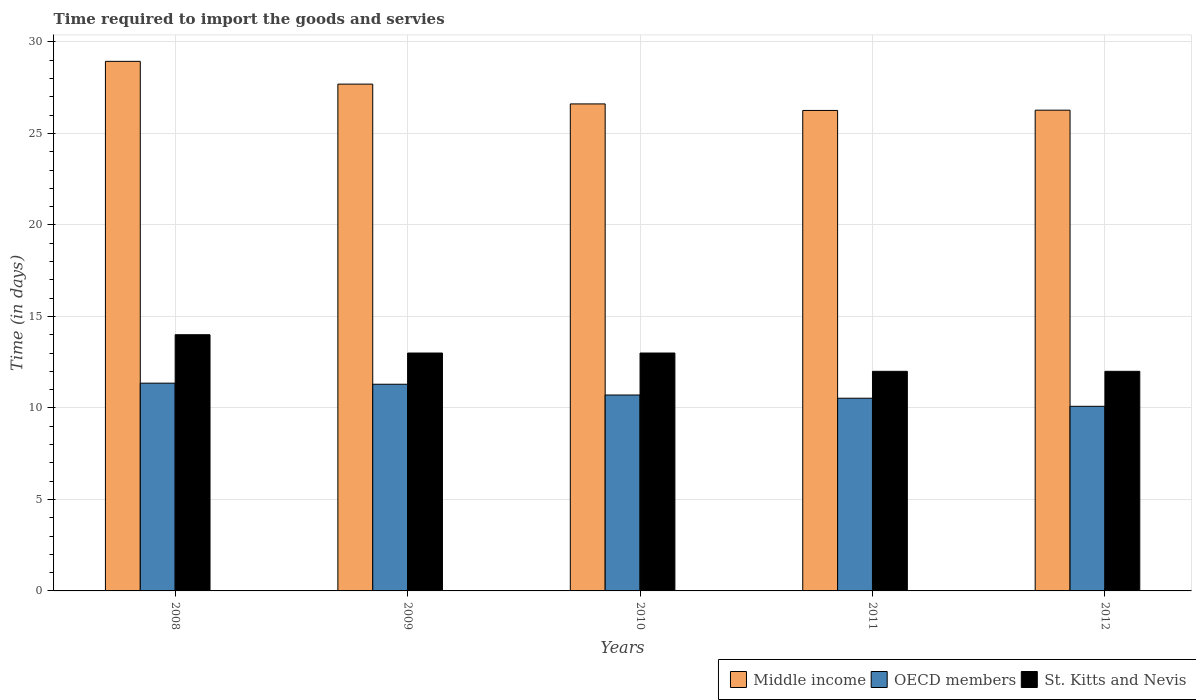How many groups of bars are there?
Provide a succinct answer. 5. In how many cases, is the number of bars for a given year not equal to the number of legend labels?
Your answer should be very brief. 0. What is the number of days required to import the goods and services in Middle income in 2009?
Provide a short and direct response. 27.69. Across all years, what is the maximum number of days required to import the goods and services in St. Kitts and Nevis?
Your response must be concise. 14. Across all years, what is the minimum number of days required to import the goods and services in St. Kitts and Nevis?
Provide a short and direct response. 12. In which year was the number of days required to import the goods and services in Middle income maximum?
Offer a very short reply. 2008. In which year was the number of days required to import the goods and services in Middle income minimum?
Your response must be concise. 2011. What is the total number of days required to import the goods and services in St. Kitts and Nevis in the graph?
Keep it short and to the point. 64. What is the difference between the number of days required to import the goods and services in OECD members in 2008 and that in 2011?
Provide a short and direct response. 0.82. What is the difference between the number of days required to import the goods and services in St. Kitts and Nevis in 2008 and the number of days required to import the goods and services in Middle income in 2012?
Provide a short and direct response. -12.27. What is the average number of days required to import the goods and services in St. Kitts and Nevis per year?
Ensure brevity in your answer.  12.8. In the year 2011, what is the difference between the number of days required to import the goods and services in Middle income and number of days required to import the goods and services in OECD members?
Ensure brevity in your answer.  15.73. In how many years, is the number of days required to import the goods and services in St. Kitts and Nevis greater than 14 days?
Keep it short and to the point. 0. What is the ratio of the number of days required to import the goods and services in Middle income in 2011 to that in 2012?
Offer a very short reply. 1. Is the number of days required to import the goods and services in St. Kitts and Nevis in 2011 less than that in 2012?
Offer a terse response. No. Is the difference between the number of days required to import the goods and services in Middle income in 2008 and 2010 greater than the difference between the number of days required to import the goods and services in OECD members in 2008 and 2010?
Your response must be concise. Yes. What is the difference between the highest and the second highest number of days required to import the goods and services in St. Kitts and Nevis?
Your response must be concise. 1. What is the difference between the highest and the lowest number of days required to import the goods and services in OECD members?
Make the answer very short. 1.26. Is the sum of the number of days required to import the goods and services in St. Kitts and Nevis in 2009 and 2010 greater than the maximum number of days required to import the goods and services in Middle income across all years?
Your answer should be compact. No. What does the 1st bar from the left in 2010 represents?
Your response must be concise. Middle income. What does the 1st bar from the right in 2009 represents?
Make the answer very short. St. Kitts and Nevis. How many bars are there?
Ensure brevity in your answer.  15. How many years are there in the graph?
Offer a very short reply. 5. Are the values on the major ticks of Y-axis written in scientific E-notation?
Offer a very short reply. No. Where does the legend appear in the graph?
Provide a short and direct response. Bottom right. How many legend labels are there?
Make the answer very short. 3. How are the legend labels stacked?
Offer a very short reply. Horizontal. What is the title of the graph?
Your answer should be very brief. Time required to import the goods and servies. What is the label or title of the Y-axis?
Give a very brief answer. Time (in days). What is the Time (in days) of Middle income in 2008?
Your response must be concise. 28.94. What is the Time (in days) of OECD members in 2008?
Keep it short and to the point. 11.35. What is the Time (in days) of Middle income in 2009?
Offer a very short reply. 27.69. What is the Time (in days) of OECD members in 2009?
Ensure brevity in your answer.  11.29. What is the Time (in days) of Middle income in 2010?
Offer a terse response. 26.61. What is the Time (in days) in OECD members in 2010?
Keep it short and to the point. 10.71. What is the Time (in days) of St. Kitts and Nevis in 2010?
Make the answer very short. 13. What is the Time (in days) of Middle income in 2011?
Provide a succinct answer. 26.26. What is the Time (in days) of OECD members in 2011?
Your answer should be very brief. 10.53. What is the Time (in days) of St. Kitts and Nevis in 2011?
Offer a terse response. 12. What is the Time (in days) of Middle income in 2012?
Ensure brevity in your answer.  26.27. What is the Time (in days) in OECD members in 2012?
Ensure brevity in your answer.  10.09. Across all years, what is the maximum Time (in days) of Middle income?
Ensure brevity in your answer.  28.94. Across all years, what is the maximum Time (in days) in OECD members?
Ensure brevity in your answer.  11.35. Across all years, what is the maximum Time (in days) of St. Kitts and Nevis?
Offer a very short reply. 14. Across all years, what is the minimum Time (in days) in Middle income?
Your answer should be very brief. 26.26. Across all years, what is the minimum Time (in days) of OECD members?
Your answer should be very brief. 10.09. What is the total Time (in days) in Middle income in the graph?
Your answer should be very brief. 135.77. What is the total Time (in days) of OECD members in the graph?
Provide a short and direct response. 53.97. What is the difference between the Time (in days) in Middle income in 2008 and that in 2009?
Your answer should be compact. 1.24. What is the difference between the Time (in days) in OECD members in 2008 and that in 2009?
Give a very brief answer. 0.06. What is the difference between the Time (in days) of Middle income in 2008 and that in 2010?
Your answer should be compact. 2.33. What is the difference between the Time (in days) of OECD members in 2008 and that in 2010?
Your answer should be very brief. 0.65. What is the difference between the Time (in days) of St. Kitts and Nevis in 2008 and that in 2010?
Keep it short and to the point. 1. What is the difference between the Time (in days) of Middle income in 2008 and that in 2011?
Make the answer very short. 2.68. What is the difference between the Time (in days) of OECD members in 2008 and that in 2011?
Offer a very short reply. 0.82. What is the difference between the Time (in days) in St. Kitts and Nevis in 2008 and that in 2011?
Provide a succinct answer. 2. What is the difference between the Time (in days) of Middle income in 2008 and that in 2012?
Offer a very short reply. 2.67. What is the difference between the Time (in days) in OECD members in 2008 and that in 2012?
Your response must be concise. 1.26. What is the difference between the Time (in days) in Middle income in 2009 and that in 2010?
Your answer should be very brief. 1.08. What is the difference between the Time (in days) in OECD members in 2009 and that in 2010?
Offer a very short reply. 0.59. What is the difference between the Time (in days) of Middle income in 2009 and that in 2011?
Provide a short and direct response. 1.44. What is the difference between the Time (in days) in OECD members in 2009 and that in 2011?
Provide a short and direct response. 0.76. What is the difference between the Time (in days) in St. Kitts and Nevis in 2009 and that in 2011?
Give a very brief answer. 1. What is the difference between the Time (in days) of Middle income in 2009 and that in 2012?
Provide a succinct answer. 1.42. What is the difference between the Time (in days) in OECD members in 2009 and that in 2012?
Make the answer very short. 1.21. What is the difference between the Time (in days) in Middle income in 2010 and that in 2011?
Your answer should be compact. 0.36. What is the difference between the Time (in days) of OECD members in 2010 and that in 2011?
Your answer should be very brief. 0.18. What is the difference between the Time (in days) in Middle income in 2010 and that in 2012?
Provide a succinct answer. 0.34. What is the difference between the Time (in days) in OECD members in 2010 and that in 2012?
Provide a short and direct response. 0.62. What is the difference between the Time (in days) of Middle income in 2011 and that in 2012?
Your answer should be very brief. -0.01. What is the difference between the Time (in days) of OECD members in 2011 and that in 2012?
Keep it short and to the point. 0.44. What is the difference between the Time (in days) of St. Kitts and Nevis in 2011 and that in 2012?
Provide a short and direct response. 0. What is the difference between the Time (in days) of Middle income in 2008 and the Time (in days) of OECD members in 2009?
Offer a terse response. 17.64. What is the difference between the Time (in days) of Middle income in 2008 and the Time (in days) of St. Kitts and Nevis in 2009?
Your response must be concise. 15.94. What is the difference between the Time (in days) in OECD members in 2008 and the Time (in days) in St. Kitts and Nevis in 2009?
Keep it short and to the point. -1.65. What is the difference between the Time (in days) of Middle income in 2008 and the Time (in days) of OECD members in 2010?
Keep it short and to the point. 18.23. What is the difference between the Time (in days) of Middle income in 2008 and the Time (in days) of St. Kitts and Nevis in 2010?
Your response must be concise. 15.94. What is the difference between the Time (in days) of OECD members in 2008 and the Time (in days) of St. Kitts and Nevis in 2010?
Make the answer very short. -1.65. What is the difference between the Time (in days) in Middle income in 2008 and the Time (in days) in OECD members in 2011?
Your answer should be very brief. 18.41. What is the difference between the Time (in days) in Middle income in 2008 and the Time (in days) in St. Kitts and Nevis in 2011?
Provide a succinct answer. 16.94. What is the difference between the Time (in days) in OECD members in 2008 and the Time (in days) in St. Kitts and Nevis in 2011?
Provide a short and direct response. -0.65. What is the difference between the Time (in days) of Middle income in 2008 and the Time (in days) of OECD members in 2012?
Keep it short and to the point. 18.85. What is the difference between the Time (in days) of Middle income in 2008 and the Time (in days) of St. Kitts and Nevis in 2012?
Your response must be concise. 16.94. What is the difference between the Time (in days) of OECD members in 2008 and the Time (in days) of St. Kitts and Nevis in 2012?
Provide a succinct answer. -0.65. What is the difference between the Time (in days) in Middle income in 2009 and the Time (in days) in OECD members in 2010?
Your answer should be compact. 16.99. What is the difference between the Time (in days) in Middle income in 2009 and the Time (in days) in St. Kitts and Nevis in 2010?
Make the answer very short. 14.69. What is the difference between the Time (in days) in OECD members in 2009 and the Time (in days) in St. Kitts and Nevis in 2010?
Provide a short and direct response. -1.71. What is the difference between the Time (in days) of Middle income in 2009 and the Time (in days) of OECD members in 2011?
Offer a terse response. 17.16. What is the difference between the Time (in days) of Middle income in 2009 and the Time (in days) of St. Kitts and Nevis in 2011?
Provide a succinct answer. 15.69. What is the difference between the Time (in days) of OECD members in 2009 and the Time (in days) of St. Kitts and Nevis in 2011?
Make the answer very short. -0.71. What is the difference between the Time (in days) in Middle income in 2009 and the Time (in days) in OECD members in 2012?
Offer a terse response. 17.61. What is the difference between the Time (in days) of Middle income in 2009 and the Time (in days) of St. Kitts and Nevis in 2012?
Your answer should be very brief. 15.69. What is the difference between the Time (in days) in OECD members in 2009 and the Time (in days) in St. Kitts and Nevis in 2012?
Provide a succinct answer. -0.71. What is the difference between the Time (in days) of Middle income in 2010 and the Time (in days) of OECD members in 2011?
Ensure brevity in your answer.  16.08. What is the difference between the Time (in days) of Middle income in 2010 and the Time (in days) of St. Kitts and Nevis in 2011?
Your response must be concise. 14.61. What is the difference between the Time (in days) in OECD members in 2010 and the Time (in days) in St. Kitts and Nevis in 2011?
Provide a short and direct response. -1.29. What is the difference between the Time (in days) in Middle income in 2010 and the Time (in days) in OECD members in 2012?
Your answer should be very brief. 16.52. What is the difference between the Time (in days) in Middle income in 2010 and the Time (in days) in St. Kitts and Nevis in 2012?
Ensure brevity in your answer.  14.61. What is the difference between the Time (in days) in OECD members in 2010 and the Time (in days) in St. Kitts and Nevis in 2012?
Offer a very short reply. -1.29. What is the difference between the Time (in days) of Middle income in 2011 and the Time (in days) of OECD members in 2012?
Give a very brief answer. 16.17. What is the difference between the Time (in days) in Middle income in 2011 and the Time (in days) in St. Kitts and Nevis in 2012?
Ensure brevity in your answer.  14.26. What is the difference between the Time (in days) of OECD members in 2011 and the Time (in days) of St. Kitts and Nevis in 2012?
Offer a terse response. -1.47. What is the average Time (in days) in Middle income per year?
Your answer should be compact. 27.15. What is the average Time (in days) of OECD members per year?
Keep it short and to the point. 10.79. In the year 2008, what is the difference between the Time (in days) in Middle income and Time (in days) in OECD members?
Offer a terse response. 17.59. In the year 2008, what is the difference between the Time (in days) of Middle income and Time (in days) of St. Kitts and Nevis?
Provide a succinct answer. 14.94. In the year 2008, what is the difference between the Time (in days) in OECD members and Time (in days) in St. Kitts and Nevis?
Offer a terse response. -2.65. In the year 2009, what is the difference between the Time (in days) in Middle income and Time (in days) in OECD members?
Make the answer very short. 16.4. In the year 2009, what is the difference between the Time (in days) of Middle income and Time (in days) of St. Kitts and Nevis?
Give a very brief answer. 14.69. In the year 2009, what is the difference between the Time (in days) of OECD members and Time (in days) of St. Kitts and Nevis?
Offer a very short reply. -1.71. In the year 2010, what is the difference between the Time (in days) in Middle income and Time (in days) in OECD members?
Your answer should be very brief. 15.91. In the year 2010, what is the difference between the Time (in days) of Middle income and Time (in days) of St. Kitts and Nevis?
Make the answer very short. 13.61. In the year 2010, what is the difference between the Time (in days) in OECD members and Time (in days) in St. Kitts and Nevis?
Offer a terse response. -2.29. In the year 2011, what is the difference between the Time (in days) in Middle income and Time (in days) in OECD members?
Provide a succinct answer. 15.73. In the year 2011, what is the difference between the Time (in days) in Middle income and Time (in days) in St. Kitts and Nevis?
Your answer should be very brief. 14.26. In the year 2011, what is the difference between the Time (in days) of OECD members and Time (in days) of St. Kitts and Nevis?
Provide a short and direct response. -1.47. In the year 2012, what is the difference between the Time (in days) of Middle income and Time (in days) of OECD members?
Your answer should be compact. 16.18. In the year 2012, what is the difference between the Time (in days) in Middle income and Time (in days) in St. Kitts and Nevis?
Make the answer very short. 14.27. In the year 2012, what is the difference between the Time (in days) in OECD members and Time (in days) in St. Kitts and Nevis?
Offer a terse response. -1.91. What is the ratio of the Time (in days) of Middle income in 2008 to that in 2009?
Keep it short and to the point. 1.04. What is the ratio of the Time (in days) in OECD members in 2008 to that in 2009?
Your response must be concise. 1.01. What is the ratio of the Time (in days) in St. Kitts and Nevis in 2008 to that in 2009?
Keep it short and to the point. 1.08. What is the ratio of the Time (in days) of Middle income in 2008 to that in 2010?
Offer a very short reply. 1.09. What is the ratio of the Time (in days) of OECD members in 2008 to that in 2010?
Provide a succinct answer. 1.06. What is the ratio of the Time (in days) of St. Kitts and Nevis in 2008 to that in 2010?
Your answer should be very brief. 1.08. What is the ratio of the Time (in days) in Middle income in 2008 to that in 2011?
Keep it short and to the point. 1.1. What is the ratio of the Time (in days) in OECD members in 2008 to that in 2011?
Ensure brevity in your answer.  1.08. What is the ratio of the Time (in days) of St. Kitts and Nevis in 2008 to that in 2011?
Your response must be concise. 1.17. What is the ratio of the Time (in days) in Middle income in 2008 to that in 2012?
Your answer should be very brief. 1.1. What is the ratio of the Time (in days) of OECD members in 2008 to that in 2012?
Provide a short and direct response. 1.13. What is the ratio of the Time (in days) in St. Kitts and Nevis in 2008 to that in 2012?
Give a very brief answer. 1.17. What is the ratio of the Time (in days) in Middle income in 2009 to that in 2010?
Provide a succinct answer. 1.04. What is the ratio of the Time (in days) in OECD members in 2009 to that in 2010?
Provide a short and direct response. 1.05. What is the ratio of the Time (in days) in St. Kitts and Nevis in 2009 to that in 2010?
Provide a succinct answer. 1. What is the ratio of the Time (in days) in Middle income in 2009 to that in 2011?
Provide a succinct answer. 1.05. What is the ratio of the Time (in days) in OECD members in 2009 to that in 2011?
Your answer should be compact. 1.07. What is the ratio of the Time (in days) of Middle income in 2009 to that in 2012?
Your answer should be compact. 1.05. What is the ratio of the Time (in days) of OECD members in 2009 to that in 2012?
Make the answer very short. 1.12. What is the ratio of the Time (in days) of St. Kitts and Nevis in 2009 to that in 2012?
Provide a succinct answer. 1.08. What is the ratio of the Time (in days) in Middle income in 2010 to that in 2011?
Your answer should be very brief. 1.01. What is the ratio of the Time (in days) in OECD members in 2010 to that in 2011?
Your answer should be very brief. 1.02. What is the ratio of the Time (in days) of Middle income in 2010 to that in 2012?
Offer a terse response. 1.01. What is the ratio of the Time (in days) in OECD members in 2010 to that in 2012?
Make the answer very short. 1.06. What is the ratio of the Time (in days) of Middle income in 2011 to that in 2012?
Offer a very short reply. 1. What is the ratio of the Time (in days) of OECD members in 2011 to that in 2012?
Provide a succinct answer. 1.04. What is the difference between the highest and the second highest Time (in days) in Middle income?
Offer a terse response. 1.24. What is the difference between the highest and the second highest Time (in days) in OECD members?
Your response must be concise. 0.06. What is the difference between the highest and the lowest Time (in days) in Middle income?
Your answer should be very brief. 2.68. What is the difference between the highest and the lowest Time (in days) of OECD members?
Give a very brief answer. 1.26. What is the difference between the highest and the lowest Time (in days) of St. Kitts and Nevis?
Your answer should be compact. 2. 